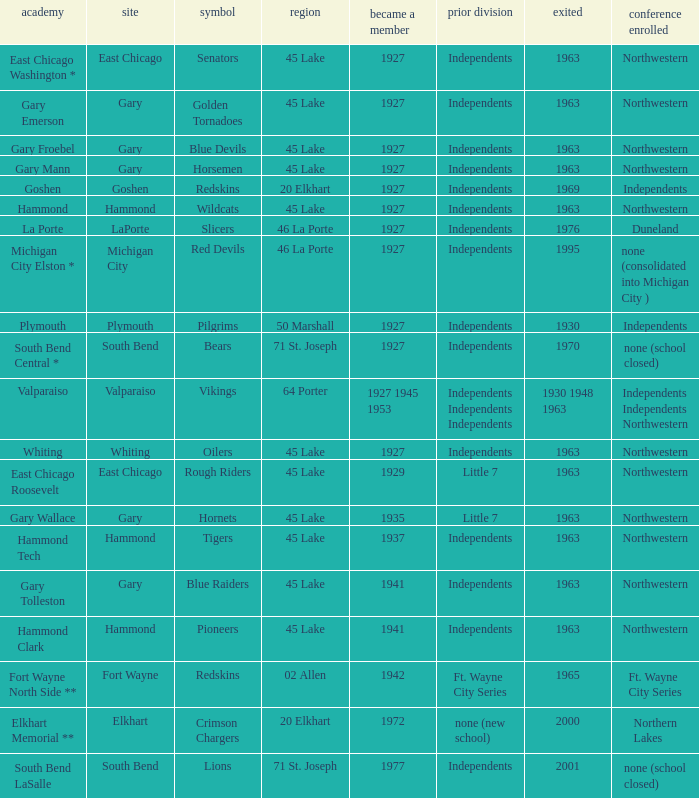When doeas Mascot of blue devils in Gary Froebel School? 1927.0. 